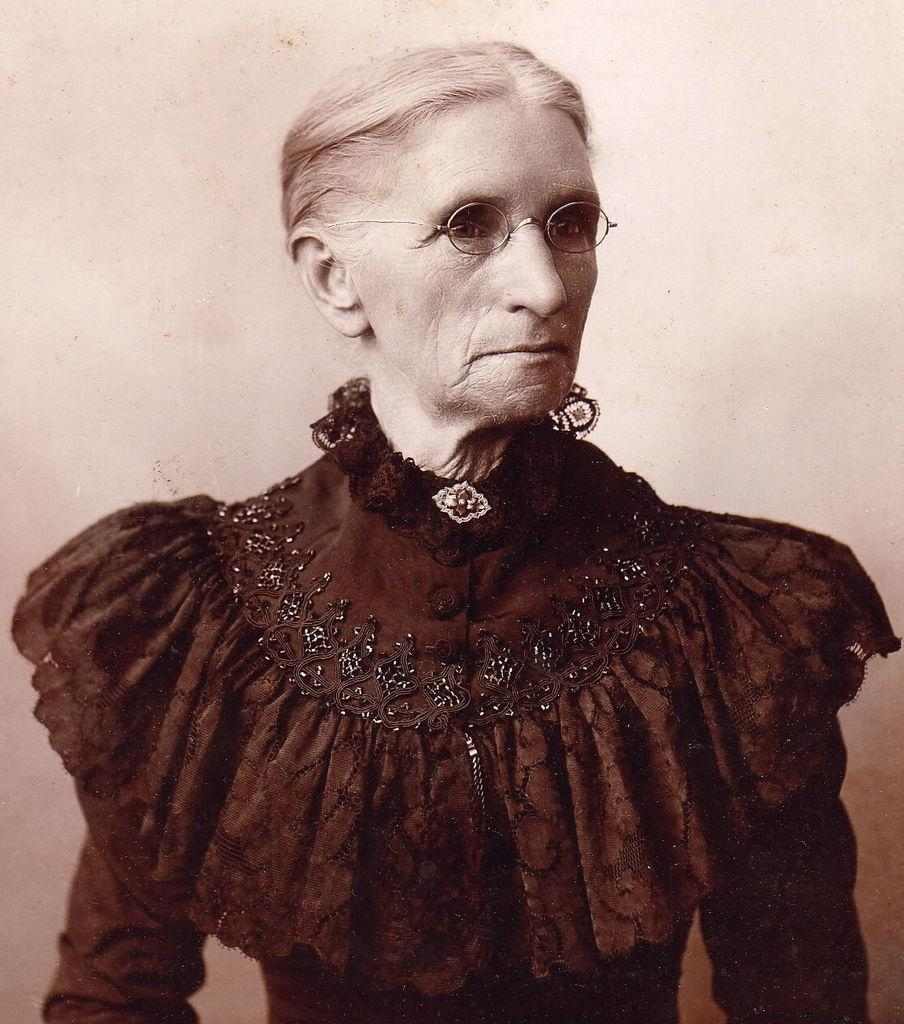Who is the main subject in the image? There is an old woman in the center of the image. What can be seen in the background of the image? There is a wall in the background of the image. What type of boats are visible in the image? There are no boats present in the image. What is the old woman doing in the image? The provided facts do not specify what the old woman is doing in the image. 